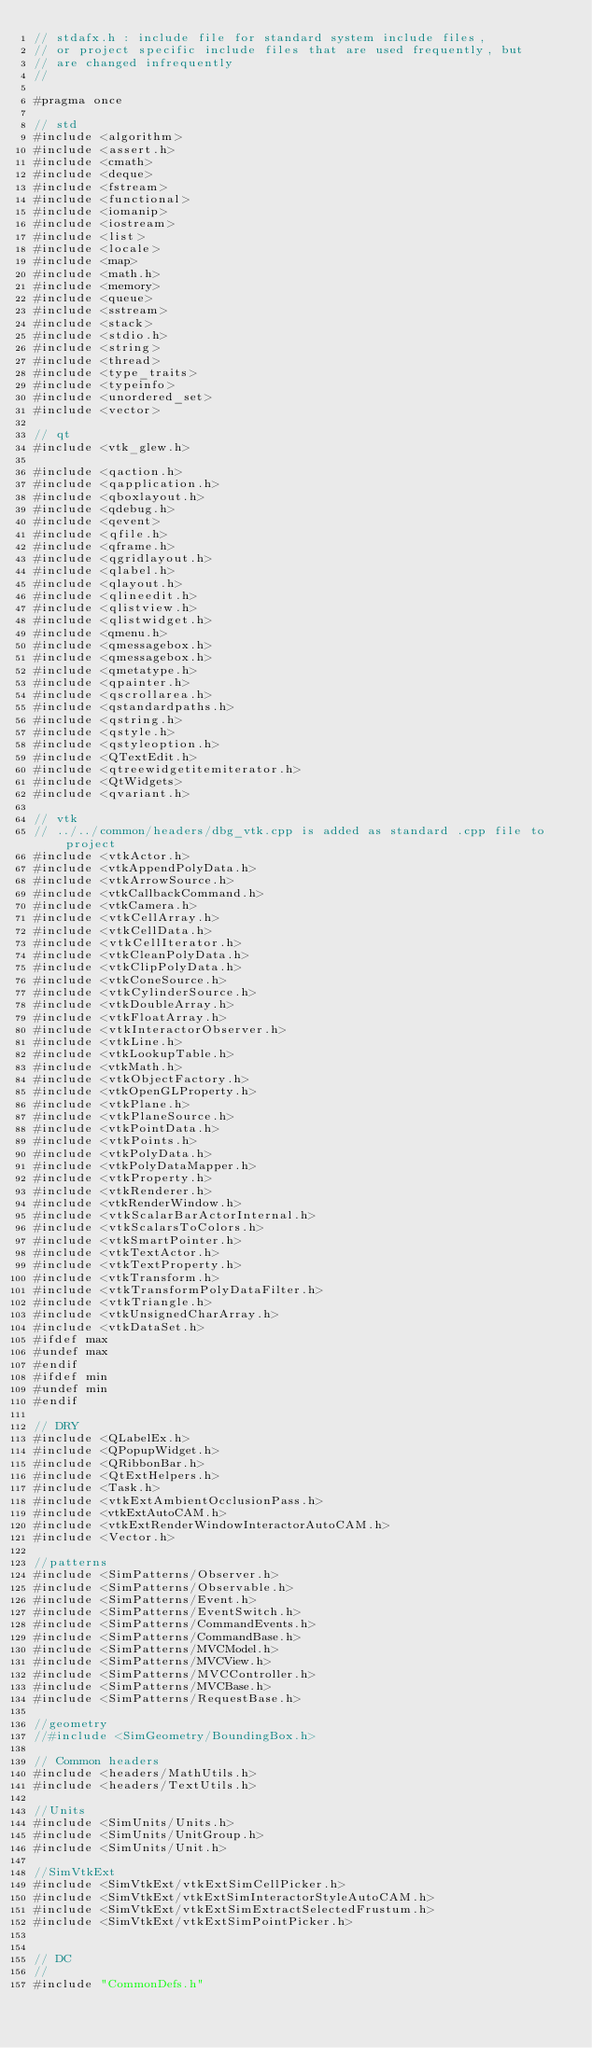Convert code to text. <code><loc_0><loc_0><loc_500><loc_500><_C_>// stdafx.h : include file for standard system include files,
// or project specific include files that are used frequently, but
// are changed infrequently
//

#pragma once

// std
#include <algorithm>
#include <assert.h>
#include <cmath>
#include <deque>
#include <fstream>
#include <functional>
#include <iomanip>
#include <iostream>
#include <list>
#include <locale>
#include <map>
#include <math.h>
#include <memory>
#include <queue>
#include <sstream>
#include <stack>
#include <stdio.h>
#include <string>
#include <thread>
#include <type_traits>
#include <typeinfo>
#include <unordered_set>
#include <vector>

// qt
#include <vtk_glew.h>

#include <qaction.h>
#include <qapplication.h>
#include <qboxlayout.h>
#include <qdebug.h>
#include <qevent>
#include <qfile.h>
#include <qframe.h>
#include <qgridlayout.h>
#include <qlabel.h>
#include <qlayout.h>
#include <qlineedit.h>
#include <qlistview.h>
#include <qlistwidget.h>
#include <qmenu.h>
#include <qmessagebox.h>
#include <qmessagebox.h>
#include <qmetatype.h>
#include <qpainter.h>
#include <qscrollarea.h>
#include <qstandardpaths.h>
#include <qstring.h>
#include <qstyle.h>
#include <qstyleoption.h>
#include <QTextEdit.h>
#include <qtreewidgetitemiterator.h>
#include <QtWidgets>
#include <qvariant.h>

// vtk
// ../../common/headers/dbg_vtk.cpp is added as standard .cpp file to project
#include <vtkActor.h>
#include <vtkAppendPolyData.h>
#include <vtkArrowSource.h>
#include <vtkCallbackCommand.h>
#include <vtkCamera.h>
#include <vtkCellArray.h>
#include <vtkCellData.h>
#include <vtkCellIterator.h>
#include <vtkCleanPolyData.h>
#include <vtkClipPolyData.h>
#include <vtkConeSource.h>
#include <vtkCylinderSource.h>
#include <vtkDoubleArray.h>
#include <vtkFloatArray.h>
#include <vtkInteractorObserver.h>
#include <vtkLine.h>
#include <vtkLookupTable.h>
#include <vtkMath.h>
#include <vtkObjectFactory.h>
#include <vtkOpenGLProperty.h>
#include <vtkPlane.h>
#include <vtkPlaneSource.h>
#include <vtkPointData.h>
#include <vtkPoints.h>
#include <vtkPolyData.h>
#include <vtkPolyDataMapper.h>
#include <vtkProperty.h>
#include <vtkRenderer.h>
#include <vtkRenderWindow.h>
#include <vtkScalarBarActorInternal.h>
#include <vtkScalarsToColors.h>
#include <vtkSmartPointer.h>
#include <vtkTextActor.h>
#include <vtkTextProperty.h>
#include <vtkTransform.h>
#include <vtkTransformPolyDataFilter.h>
#include <vtkTriangle.h>
#include <vtkUnsignedCharArray.h>
#include <vtkDataSet.h>
#ifdef max
#undef max
#endif
#ifdef min
#undef min
#endif

// DRY
#include <QLabelEx.h>
#include <QPopupWidget.h>
#include <QRibbonBar.h>
#include <QtExtHelpers.h>
#include <Task.h>
#include <vtkExtAmbientOcclusionPass.h>
#include <vtkExtAutoCAM.h>
#include <vtkExtRenderWindowInteractorAutoCAM.h>
#include <Vector.h>

//patterns
#include <SimPatterns/Observer.h>
#include <SimPatterns/Observable.h>
#include <SimPatterns/Event.h>
#include <SimPatterns/EventSwitch.h>
#include <SimPatterns/CommandEvents.h>
#include <SimPatterns/CommandBase.h>
#include <SimPatterns/MVCModel.h>
#include <SimPatterns/MVCView.h>
#include <SimPatterns/MVCController.h>
#include <SimPatterns/MVCBase.h>
#include <SimPatterns/RequestBase.h>

//geometry
//#include <SimGeometry/BoundingBox.h>

// Common headers
#include <headers/MathUtils.h>
#include <headers/TextUtils.h>

//Units
#include <SimUnits/Units.h>
#include <SimUnits/UnitGroup.h>
#include <SimUnits/Unit.h>

//SimVtkExt
#include <SimVtkExt/vtkExtSimCellPicker.h>
#include <SimVtkExt/vtkExtSimInteractorStyleAutoCAM.h>
#include <SimVtkExt/vtkExtSimExtractSelectedFrustum.h>
#include <SimVtkExt/vtkExtSimPointPicker.h>


// DC
//
#include "CommonDefs.h"
</code> 